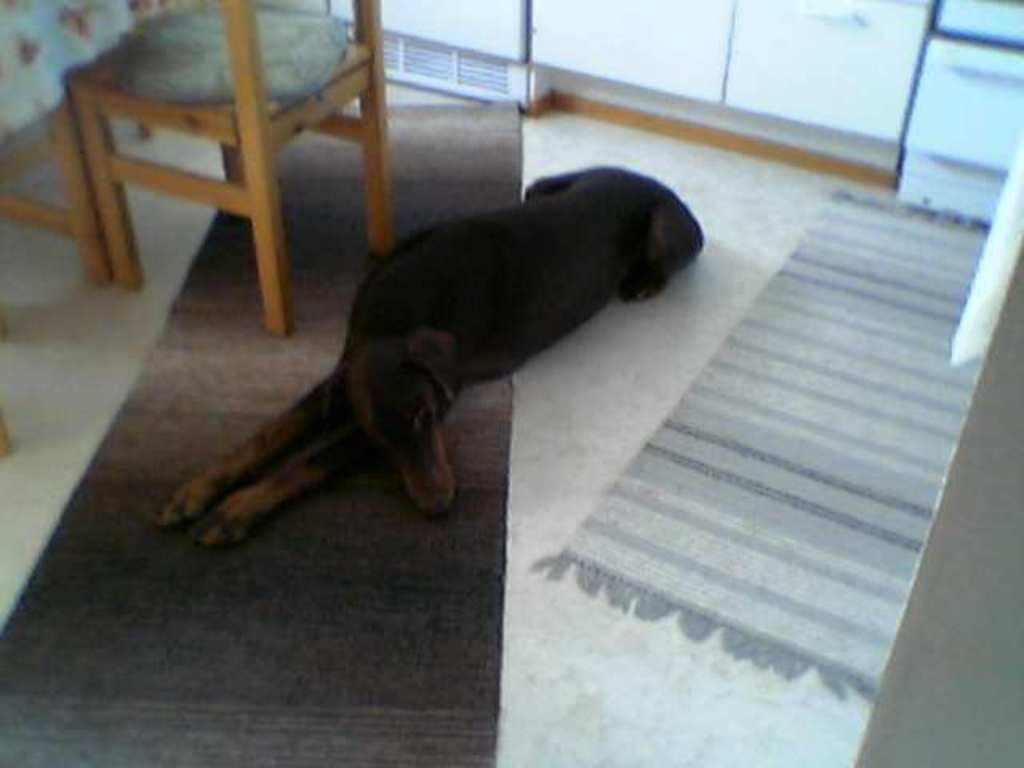What animal is present in the image? There is a dog in the image. What position is the dog in? The dog is lying on the floor. Where is the dog located in relation to other objects in the image? The dog is beside a chair. What type of secretary is the dog performing in the image? There is no secretary or any secretarial work being performed in the image; the dog is simply lying on the floor beside a chair. 